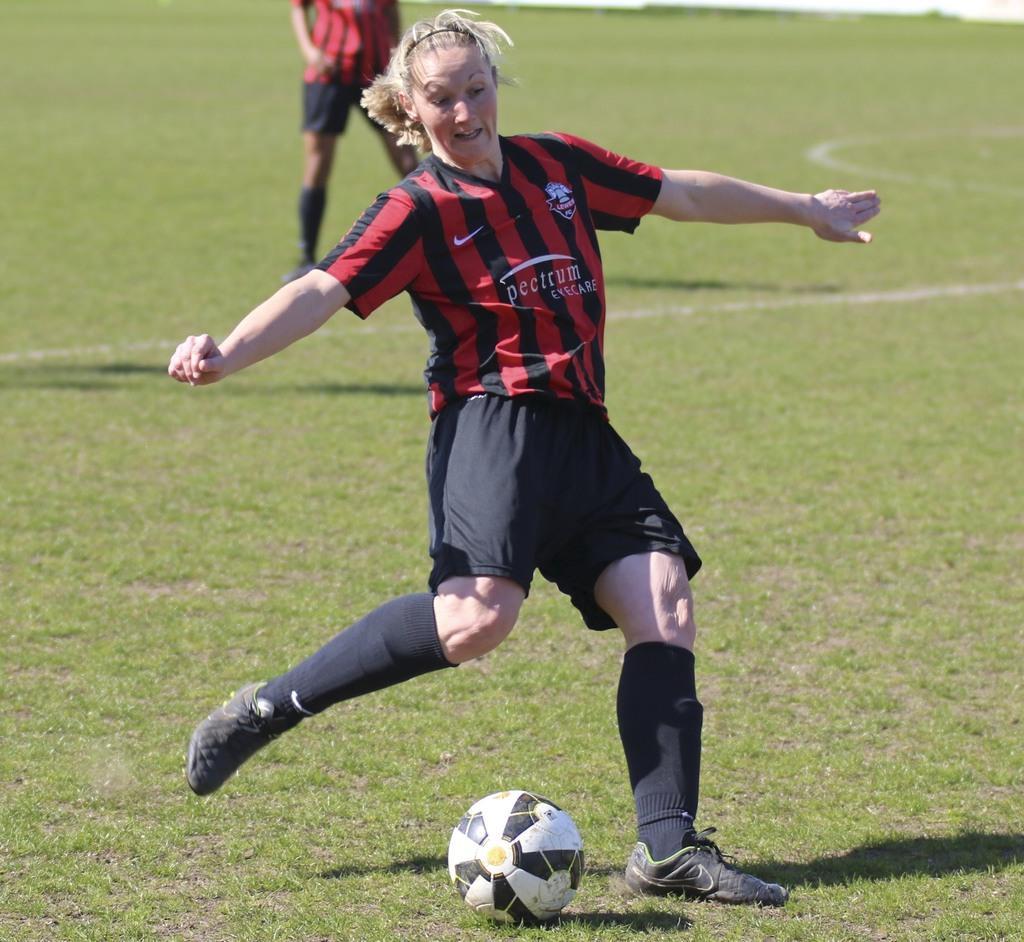Describe this image in one or two sentences. This woman is running as there is a leg movement. In-front of this woman there is a ball on grass. Far a person is standing. 